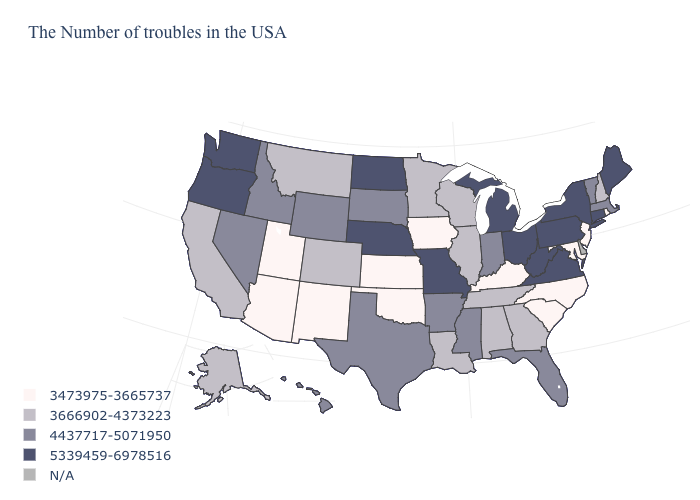Does New Mexico have the lowest value in the USA?
Write a very short answer. Yes. What is the value of Ohio?
Quick response, please. 5339459-6978516. What is the value of Florida?
Short answer required. 4437717-5071950. Among the states that border Idaho , does Utah have the lowest value?
Give a very brief answer. Yes. Name the states that have a value in the range N/A?
Keep it brief. Delaware. What is the lowest value in the USA?
Write a very short answer. 3473975-3665737. Does Maryland have the lowest value in the USA?
Give a very brief answer. Yes. Among the states that border North Dakota , which have the highest value?
Short answer required. South Dakota. Which states have the lowest value in the West?
Quick response, please. New Mexico, Utah, Arizona. What is the lowest value in states that border Mississippi?
Short answer required. 3666902-4373223. Does the first symbol in the legend represent the smallest category?
Concise answer only. Yes. Which states have the lowest value in the USA?
Write a very short answer. Rhode Island, New Jersey, Maryland, North Carolina, South Carolina, Kentucky, Iowa, Kansas, Oklahoma, New Mexico, Utah, Arizona. What is the lowest value in the USA?
Write a very short answer. 3473975-3665737. Among the states that border Connecticut , does Rhode Island have the highest value?
Keep it brief. No. Does Montana have the lowest value in the West?
Concise answer only. No. 